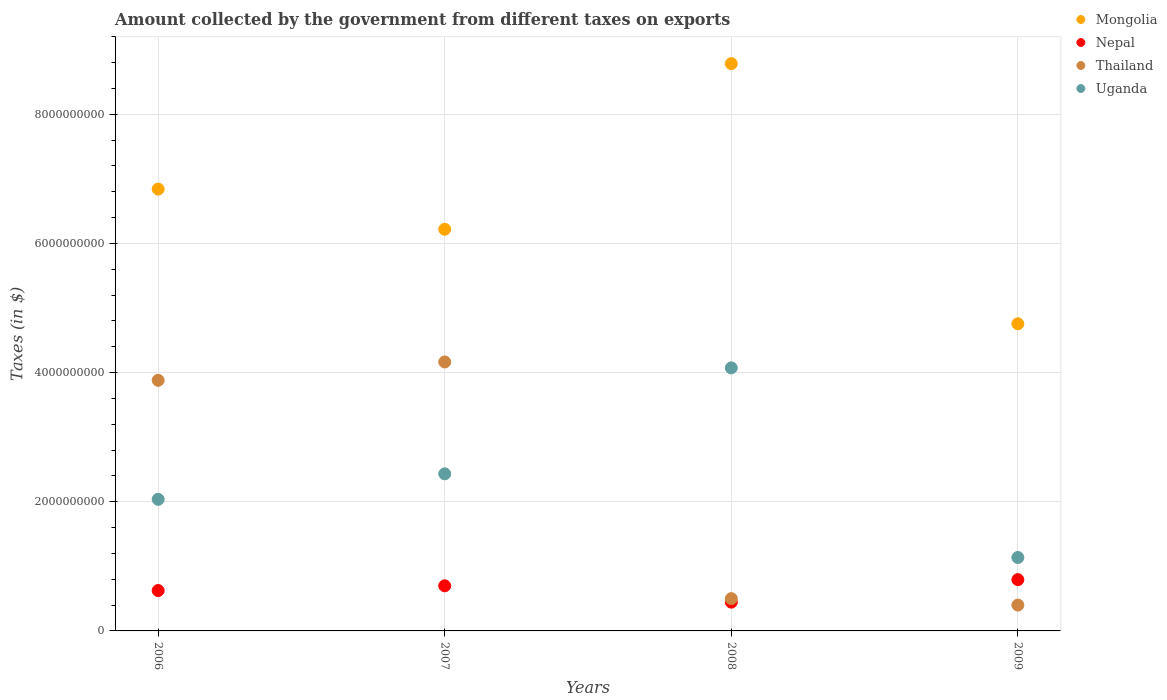How many different coloured dotlines are there?
Provide a succinct answer. 4. What is the amount collected by the government from taxes on exports in Uganda in 2007?
Provide a short and direct response. 2.43e+09. Across all years, what is the maximum amount collected by the government from taxes on exports in Thailand?
Provide a short and direct response. 4.16e+09. Across all years, what is the minimum amount collected by the government from taxes on exports in Uganda?
Your answer should be very brief. 1.14e+09. In which year was the amount collected by the government from taxes on exports in Nepal minimum?
Keep it short and to the point. 2008. What is the total amount collected by the government from taxes on exports in Thailand in the graph?
Keep it short and to the point. 8.94e+09. What is the difference between the amount collected by the government from taxes on exports in Nepal in 2007 and that in 2008?
Provide a succinct answer. 2.53e+08. What is the difference between the amount collected by the government from taxes on exports in Mongolia in 2008 and the amount collected by the government from taxes on exports in Nepal in 2007?
Ensure brevity in your answer.  8.08e+09. What is the average amount collected by the government from taxes on exports in Thailand per year?
Give a very brief answer. 2.24e+09. In the year 2006, what is the difference between the amount collected by the government from taxes on exports in Nepal and amount collected by the government from taxes on exports in Thailand?
Your answer should be very brief. -3.25e+09. What is the ratio of the amount collected by the government from taxes on exports in Nepal in 2007 to that in 2009?
Offer a very short reply. 0.88. What is the difference between the highest and the second highest amount collected by the government from taxes on exports in Thailand?
Ensure brevity in your answer.  2.84e+08. What is the difference between the highest and the lowest amount collected by the government from taxes on exports in Mongolia?
Ensure brevity in your answer.  4.03e+09. In how many years, is the amount collected by the government from taxes on exports in Thailand greater than the average amount collected by the government from taxes on exports in Thailand taken over all years?
Your answer should be compact. 2. Is the sum of the amount collected by the government from taxes on exports in Nepal in 2006 and 2007 greater than the maximum amount collected by the government from taxes on exports in Uganda across all years?
Ensure brevity in your answer.  No. Is it the case that in every year, the sum of the amount collected by the government from taxes on exports in Nepal and amount collected by the government from taxes on exports in Mongolia  is greater than the sum of amount collected by the government from taxes on exports in Thailand and amount collected by the government from taxes on exports in Uganda?
Your answer should be very brief. Yes. Is it the case that in every year, the sum of the amount collected by the government from taxes on exports in Thailand and amount collected by the government from taxes on exports in Nepal  is greater than the amount collected by the government from taxes on exports in Mongolia?
Your answer should be compact. No. Does the amount collected by the government from taxes on exports in Uganda monotonically increase over the years?
Keep it short and to the point. No. Is the amount collected by the government from taxes on exports in Nepal strictly less than the amount collected by the government from taxes on exports in Thailand over the years?
Provide a short and direct response. No. How many dotlines are there?
Provide a short and direct response. 4. How many years are there in the graph?
Ensure brevity in your answer.  4. What is the difference between two consecutive major ticks on the Y-axis?
Your answer should be very brief. 2.00e+09. Where does the legend appear in the graph?
Provide a succinct answer. Top right. What is the title of the graph?
Ensure brevity in your answer.  Amount collected by the government from different taxes on exports. Does "Norway" appear as one of the legend labels in the graph?
Offer a very short reply. No. What is the label or title of the X-axis?
Ensure brevity in your answer.  Years. What is the label or title of the Y-axis?
Your response must be concise. Taxes (in $). What is the Taxes (in $) of Mongolia in 2006?
Keep it short and to the point. 6.84e+09. What is the Taxes (in $) of Nepal in 2006?
Provide a short and direct response. 6.25e+08. What is the Taxes (in $) in Thailand in 2006?
Offer a very short reply. 3.88e+09. What is the Taxes (in $) of Uganda in 2006?
Your response must be concise. 2.04e+09. What is the Taxes (in $) of Mongolia in 2007?
Your answer should be compact. 6.22e+09. What is the Taxes (in $) in Nepal in 2007?
Offer a very short reply. 6.99e+08. What is the Taxes (in $) of Thailand in 2007?
Provide a short and direct response. 4.16e+09. What is the Taxes (in $) in Uganda in 2007?
Offer a terse response. 2.43e+09. What is the Taxes (in $) in Mongolia in 2008?
Give a very brief answer. 8.78e+09. What is the Taxes (in $) of Nepal in 2008?
Offer a very short reply. 4.46e+08. What is the Taxes (in $) of Uganda in 2008?
Your answer should be compact. 4.07e+09. What is the Taxes (in $) of Mongolia in 2009?
Your answer should be very brief. 4.75e+09. What is the Taxes (in $) of Nepal in 2009?
Offer a very short reply. 7.94e+08. What is the Taxes (in $) in Thailand in 2009?
Give a very brief answer. 4.00e+08. What is the Taxes (in $) in Uganda in 2009?
Provide a succinct answer. 1.14e+09. Across all years, what is the maximum Taxes (in $) in Mongolia?
Provide a succinct answer. 8.78e+09. Across all years, what is the maximum Taxes (in $) in Nepal?
Offer a terse response. 7.94e+08. Across all years, what is the maximum Taxes (in $) in Thailand?
Make the answer very short. 4.16e+09. Across all years, what is the maximum Taxes (in $) in Uganda?
Your response must be concise. 4.07e+09. Across all years, what is the minimum Taxes (in $) of Mongolia?
Offer a very short reply. 4.75e+09. Across all years, what is the minimum Taxes (in $) of Nepal?
Keep it short and to the point. 4.46e+08. Across all years, what is the minimum Taxes (in $) in Thailand?
Your answer should be compact. 4.00e+08. Across all years, what is the minimum Taxes (in $) of Uganda?
Provide a succinct answer. 1.14e+09. What is the total Taxes (in $) in Mongolia in the graph?
Your answer should be compact. 2.66e+1. What is the total Taxes (in $) of Nepal in the graph?
Your answer should be very brief. 2.56e+09. What is the total Taxes (in $) of Thailand in the graph?
Provide a short and direct response. 8.94e+09. What is the total Taxes (in $) in Uganda in the graph?
Provide a short and direct response. 9.68e+09. What is the difference between the Taxes (in $) in Mongolia in 2006 and that in 2007?
Keep it short and to the point. 6.22e+08. What is the difference between the Taxes (in $) in Nepal in 2006 and that in 2007?
Give a very brief answer. -7.33e+07. What is the difference between the Taxes (in $) of Thailand in 2006 and that in 2007?
Ensure brevity in your answer.  -2.84e+08. What is the difference between the Taxes (in $) in Uganda in 2006 and that in 2007?
Your response must be concise. -3.95e+08. What is the difference between the Taxes (in $) of Mongolia in 2006 and that in 2008?
Your answer should be very brief. -1.94e+09. What is the difference between the Taxes (in $) in Nepal in 2006 and that in 2008?
Your response must be concise. 1.80e+08. What is the difference between the Taxes (in $) of Thailand in 2006 and that in 2008?
Provide a succinct answer. 3.38e+09. What is the difference between the Taxes (in $) in Uganda in 2006 and that in 2008?
Your response must be concise. -2.04e+09. What is the difference between the Taxes (in $) in Mongolia in 2006 and that in 2009?
Your response must be concise. 2.09e+09. What is the difference between the Taxes (in $) of Nepal in 2006 and that in 2009?
Your answer should be very brief. -1.69e+08. What is the difference between the Taxes (in $) in Thailand in 2006 and that in 2009?
Your response must be concise. 3.48e+09. What is the difference between the Taxes (in $) in Uganda in 2006 and that in 2009?
Your response must be concise. 9.01e+08. What is the difference between the Taxes (in $) in Mongolia in 2007 and that in 2008?
Offer a very short reply. -2.56e+09. What is the difference between the Taxes (in $) of Nepal in 2007 and that in 2008?
Offer a very short reply. 2.53e+08. What is the difference between the Taxes (in $) in Thailand in 2007 and that in 2008?
Make the answer very short. 3.66e+09. What is the difference between the Taxes (in $) in Uganda in 2007 and that in 2008?
Give a very brief answer. -1.64e+09. What is the difference between the Taxes (in $) of Mongolia in 2007 and that in 2009?
Your answer should be very brief. 1.46e+09. What is the difference between the Taxes (in $) of Nepal in 2007 and that in 2009?
Your response must be concise. -9.52e+07. What is the difference between the Taxes (in $) in Thailand in 2007 and that in 2009?
Your answer should be compact. 3.76e+09. What is the difference between the Taxes (in $) in Uganda in 2007 and that in 2009?
Provide a short and direct response. 1.30e+09. What is the difference between the Taxes (in $) in Mongolia in 2008 and that in 2009?
Your answer should be very brief. 4.03e+09. What is the difference between the Taxes (in $) of Nepal in 2008 and that in 2009?
Ensure brevity in your answer.  -3.48e+08. What is the difference between the Taxes (in $) of Thailand in 2008 and that in 2009?
Ensure brevity in your answer.  9.98e+07. What is the difference between the Taxes (in $) of Uganda in 2008 and that in 2009?
Make the answer very short. 2.94e+09. What is the difference between the Taxes (in $) of Mongolia in 2006 and the Taxes (in $) of Nepal in 2007?
Provide a succinct answer. 6.14e+09. What is the difference between the Taxes (in $) of Mongolia in 2006 and the Taxes (in $) of Thailand in 2007?
Offer a very short reply. 2.68e+09. What is the difference between the Taxes (in $) in Mongolia in 2006 and the Taxes (in $) in Uganda in 2007?
Your response must be concise. 4.41e+09. What is the difference between the Taxes (in $) in Nepal in 2006 and the Taxes (in $) in Thailand in 2007?
Your answer should be compact. -3.54e+09. What is the difference between the Taxes (in $) in Nepal in 2006 and the Taxes (in $) in Uganda in 2007?
Offer a very short reply. -1.81e+09. What is the difference between the Taxes (in $) in Thailand in 2006 and the Taxes (in $) in Uganda in 2007?
Offer a very short reply. 1.45e+09. What is the difference between the Taxes (in $) in Mongolia in 2006 and the Taxes (in $) in Nepal in 2008?
Ensure brevity in your answer.  6.39e+09. What is the difference between the Taxes (in $) of Mongolia in 2006 and the Taxes (in $) of Thailand in 2008?
Offer a terse response. 6.34e+09. What is the difference between the Taxes (in $) in Mongolia in 2006 and the Taxes (in $) in Uganda in 2008?
Your answer should be very brief. 2.77e+09. What is the difference between the Taxes (in $) of Nepal in 2006 and the Taxes (in $) of Thailand in 2008?
Your answer should be very brief. 1.25e+08. What is the difference between the Taxes (in $) of Nepal in 2006 and the Taxes (in $) of Uganda in 2008?
Keep it short and to the point. -3.45e+09. What is the difference between the Taxes (in $) in Thailand in 2006 and the Taxes (in $) in Uganda in 2008?
Provide a succinct answer. -1.93e+08. What is the difference between the Taxes (in $) of Mongolia in 2006 and the Taxes (in $) of Nepal in 2009?
Provide a succinct answer. 6.05e+09. What is the difference between the Taxes (in $) of Mongolia in 2006 and the Taxes (in $) of Thailand in 2009?
Give a very brief answer. 6.44e+09. What is the difference between the Taxes (in $) of Mongolia in 2006 and the Taxes (in $) of Uganda in 2009?
Give a very brief answer. 5.70e+09. What is the difference between the Taxes (in $) in Nepal in 2006 and the Taxes (in $) in Thailand in 2009?
Your response must be concise. 2.25e+08. What is the difference between the Taxes (in $) of Nepal in 2006 and the Taxes (in $) of Uganda in 2009?
Ensure brevity in your answer.  -5.11e+08. What is the difference between the Taxes (in $) of Thailand in 2006 and the Taxes (in $) of Uganda in 2009?
Give a very brief answer. 2.74e+09. What is the difference between the Taxes (in $) in Mongolia in 2007 and the Taxes (in $) in Nepal in 2008?
Provide a short and direct response. 5.77e+09. What is the difference between the Taxes (in $) in Mongolia in 2007 and the Taxes (in $) in Thailand in 2008?
Offer a terse response. 5.72e+09. What is the difference between the Taxes (in $) of Mongolia in 2007 and the Taxes (in $) of Uganda in 2008?
Ensure brevity in your answer.  2.15e+09. What is the difference between the Taxes (in $) in Nepal in 2007 and the Taxes (in $) in Thailand in 2008?
Your answer should be compact. 1.99e+08. What is the difference between the Taxes (in $) in Nepal in 2007 and the Taxes (in $) in Uganda in 2008?
Provide a short and direct response. -3.37e+09. What is the difference between the Taxes (in $) of Thailand in 2007 and the Taxes (in $) of Uganda in 2008?
Keep it short and to the point. 9.16e+07. What is the difference between the Taxes (in $) in Mongolia in 2007 and the Taxes (in $) in Nepal in 2009?
Offer a terse response. 5.42e+09. What is the difference between the Taxes (in $) of Mongolia in 2007 and the Taxes (in $) of Thailand in 2009?
Keep it short and to the point. 5.82e+09. What is the difference between the Taxes (in $) in Mongolia in 2007 and the Taxes (in $) in Uganda in 2009?
Provide a short and direct response. 5.08e+09. What is the difference between the Taxes (in $) of Nepal in 2007 and the Taxes (in $) of Thailand in 2009?
Your answer should be very brief. 2.98e+08. What is the difference between the Taxes (in $) in Nepal in 2007 and the Taxes (in $) in Uganda in 2009?
Offer a terse response. -4.38e+08. What is the difference between the Taxes (in $) in Thailand in 2007 and the Taxes (in $) in Uganda in 2009?
Give a very brief answer. 3.03e+09. What is the difference between the Taxes (in $) in Mongolia in 2008 and the Taxes (in $) in Nepal in 2009?
Keep it short and to the point. 7.99e+09. What is the difference between the Taxes (in $) of Mongolia in 2008 and the Taxes (in $) of Thailand in 2009?
Keep it short and to the point. 8.38e+09. What is the difference between the Taxes (in $) of Mongolia in 2008 and the Taxes (in $) of Uganda in 2009?
Offer a terse response. 7.65e+09. What is the difference between the Taxes (in $) of Nepal in 2008 and the Taxes (in $) of Thailand in 2009?
Your response must be concise. 4.54e+07. What is the difference between the Taxes (in $) in Nepal in 2008 and the Taxes (in $) in Uganda in 2009?
Provide a short and direct response. -6.91e+08. What is the difference between the Taxes (in $) in Thailand in 2008 and the Taxes (in $) in Uganda in 2009?
Ensure brevity in your answer.  -6.37e+08. What is the average Taxes (in $) of Mongolia per year?
Ensure brevity in your answer.  6.65e+09. What is the average Taxes (in $) in Nepal per year?
Your answer should be compact. 6.41e+08. What is the average Taxes (in $) of Thailand per year?
Ensure brevity in your answer.  2.24e+09. What is the average Taxes (in $) of Uganda per year?
Provide a succinct answer. 2.42e+09. In the year 2006, what is the difference between the Taxes (in $) in Mongolia and Taxes (in $) in Nepal?
Ensure brevity in your answer.  6.21e+09. In the year 2006, what is the difference between the Taxes (in $) in Mongolia and Taxes (in $) in Thailand?
Make the answer very short. 2.96e+09. In the year 2006, what is the difference between the Taxes (in $) in Mongolia and Taxes (in $) in Uganda?
Provide a short and direct response. 4.80e+09. In the year 2006, what is the difference between the Taxes (in $) of Nepal and Taxes (in $) of Thailand?
Give a very brief answer. -3.25e+09. In the year 2006, what is the difference between the Taxes (in $) of Nepal and Taxes (in $) of Uganda?
Give a very brief answer. -1.41e+09. In the year 2006, what is the difference between the Taxes (in $) in Thailand and Taxes (in $) in Uganda?
Keep it short and to the point. 1.84e+09. In the year 2007, what is the difference between the Taxes (in $) of Mongolia and Taxes (in $) of Nepal?
Give a very brief answer. 5.52e+09. In the year 2007, what is the difference between the Taxes (in $) of Mongolia and Taxes (in $) of Thailand?
Provide a succinct answer. 2.05e+09. In the year 2007, what is the difference between the Taxes (in $) of Mongolia and Taxes (in $) of Uganda?
Give a very brief answer. 3.79e+09. In the year 2007, what is the difference between the Taxes (in $) of Nepal and Taxes (in $) of Thailand?
Your response must be concise. -3.47e+09. In the year 2007, what is the difference between the Taxes (in $) in Nepal and Taxes (in $) in Uganda?
Your answer should be compact. -1.73e+09. In the year 2007, what is the difference between the Taxes (in $) in Thailand and Taxes (in $) in Uganda?
Your answer should be compact. 1.73e+09. In the year 2008, what is the difference between the Taxes (in $) in Mongolia and Taxes (in $) in Nepal?
Make the answer very short. 8.34e+09. In the year 2008, what is the difference between the Taxes (in $) in Mongolia and Taxes (in $) in Thailand?
Your answer should be compact. 8.28e+09. In the year 2008, what is the difference between the Taxes (in $) in Mongolia and Taxes (in $) in Uganda?
Give a very brief answer. 4.71e+09. In the year 2008, what is the difference between the Taxes (in $) in Nepal and Taxes (in $) in Thailand?
Keep it short and to the point. -5.44e+07. In the year 2008, what is the difference between the Taxes (in $) of Nepal and Taxes (in $) of Uganda?
Provide a succinct answer. -3.63e+09. In the year 2008, what is the difference between the Taxes (in $) in Thailand and Taxes (in $) in Uganda?
Give a very brief answer. -3.57e+09. In the year 2009, what is the difference between the Taxes (in $) in Mongolia and Taxes (in $) in Nepal?
Provide a succinct answer. 3.96e+09. In the year 2009, what is the difference between the Taxes (in $) in Mongolia and Taxes (in $) in Thailand?
Ensure brevity in your answer.  4.35e+09. In the year 2009, what is the difference between the Taxes (in $) in Mongolia and Taxes (in $) in Uganda?
Your answer should be very brief. 3.62e+09. In the year 2009, what is the difference between the Taxes (in $) of Nepal and Taxes (in $) of Thailand?
Make the answer very short. 3.94e+08. In the year 2009, what is the difference between the Taxes (in $) of Nepal and Taxes (in $) of Uganda?
Provide a short and direct response. -3.43e+08. In the year 2009, what is the difference between the Taxes (in $) of Thailand and Taxes (in $) of Uganda?
Provide a short and direct response. -7.36e+08. What is the ratio of the Taxes (in $) in Nepal in 2006 to that in 2007?
Ensure brevity in your answer.  0.9. What is the ratio of the Taxes (in $) in Thailand in 2006 to that in 2007?
Your response must be concise. 0.93. What is the ratio of the Taxes (in $) of Uganda in 2006 to that in 2007?
Offer a very short reply. 0.84. What is the ratio of the Taxes (in $) of Mongolia in 2006 to that in 2008?
Your response must be concise. 0.78. What is the ratio of the Taxes (in $) of Nepal in 2006 to that in 2008?
Provide a succinct answer. 1.4. What is the ratio of the Taxes (in $) in Thailand in 2006 to that in 2008?
Make the answer very short. 7.76. What is the ratio of the Taxes (in $) of Uganda in 2006 to that in 2008?
Your answer should be compact. 0.5. What is the ratio of the Taxes (in $) of Mongolia in 2006 to that in 2009?
Ensure brevity in your answer.  1.44. What is the ratio of the Taxes (in $) of Nepal in 2006 to that in 2009?
Offer a very short reply. 0.79. What is the ratio of the Taxes (in $) in Thailand in 2006 to that in 2009?
Offer a very short reply. 9.7. What is the ratio of the Taxes (in $) of Uganda in 2006 to that in 2009?
Your answer should be compact. 1.79. What is the ratio of the Taxes (in $) in Mongolia in 2007 to that in 2008?
Offer a very short reply. 0.71. What is the ratio of the Taxes (in $) in Nepal in 2007 to that in 2008?
Keep it short and to the point. 1.57. What is the ratio of the Taxes (in $) in Thailand in 2007 to that in 2008?
Your response must be concise. 8.33. What is the ratio of the Taxes (in $) of Uganda in 2007 to that in 2008?
Your answer should be very brief. 0.6. What is the ratio of the Taxes (in $) of Mongolia in 2007 to that in 2009?
Ensure brevity in your answer.  1.31. What is the ratio of the Taxes (in $) in Nepal in 2007 to that in 2009?
Keep it short and to the point. 0.88. What is the ratio of the Taxes (in $) of Thailand in 2007 to that in 2009?
Keep it short and to the point. 10.41. What is the ratio of the Taxes (in $) in Uganda in 2007 to that in 2009?
Your response must be concise. 2.14. What is the ratio of the Taxes (in $) of Mongolia in 2008 to that in 2009?
Make the answer very short. 1.85. What is the ratio of the Taxes (in $) in Nepal in 2008 to that in 2009?
Your answer should be very brief. 0.56. What is the ratio of the Taxes (in $) in Thailand in 2008 to that in 2009?
Your answer should be compact. 1.25. What is the ratio of the Taxes (in $) of Uganda in 2008 to that in 2009?
Ensure brevity in your answer.  3.58. What is the difference between the highest and the second highest Taxes (in $) of Mongolia?
Provide a short and direct response. 1.94e+09. What is the difference between the highest and the second highest Taxes (in $) in Nepal?
Your answer should be very brief. 9.52e+07. What is the difference between the highest and the second highest Taxes (in $) of Thailand?
Offer a very short reply. 2.84e+08. What is the difference between the highest and the second highest Taxes (in $) of Uganda?
Provide a succinct answer. 1.64e+09. What is the difference between the highest and the lowest Taxes (in $) of Mongolia?
Offer a terse response. 4.03e+09. What is the difference between the highest and the lowest Taxes (in $) in Nepal?
Give a very brief answer. 3.48e+08. What is the difference between the highest and the lowest Taxes (in $) in Thailand?
Keep it short and to the point. 3.76e+09. What is the difference between the highest and the lowest Taxes (in $) in Uganda?
Make the answer very short. 2.94e+09. 